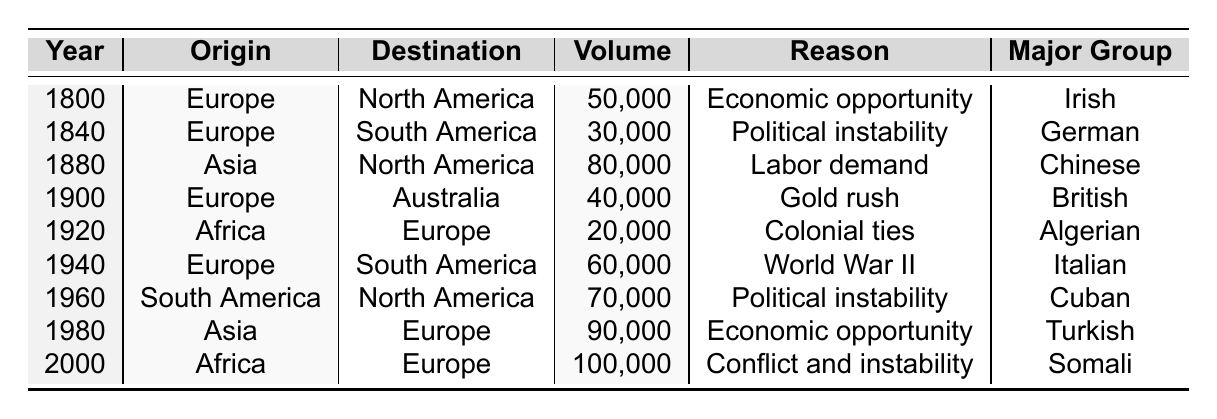What was the migration volume from Asia to North America in 1880? The table shows a migration volume of 80,000 from Asia to North America in 1880.
Answer: 80,000 Which major ethnic group migrated from South America to North America in 1960? The table indicates that the major ethnic group that migrated from South America to North America in 1960 was Cuban.
Answer: Cuban What was the primary reason for the migration from Europe to South America in 1840? According to the table, the primary reason for this migration was political instability.
Answer: Political instability Did any migration from Africa to Europe occur before 2000? The table presents data on migration from Africa to Europe in 1920, indicating that it did occur prior to 2000.
Answer: Yes What is the total migration volume from Europe to South America across all recorded years? By adding the migration volumes for Europe to South America from the years 1840 (30,000) and 1940 (60,000), we get 30,000 + 60,000 = 90,000 as the total volume.
Answer: 90,000 How many years did migration from Asia to Europe occur, according to the table? The table shows that migration from Asia to Europe occurred once in 1980, so it happened in only one year.
Answer: 1 What was the average migration volume from Africa to Europe during the years listed? The only two entries for migration from Africa to Europe are 20,000 (in 1920) and 100,000 (in 2000). The average is (20,000 + 100,000) / 2 = 60,000.
Answer: 60,000 Which year experienced the highest migration from Africa to Europe and what was the volume? The table indicates the highest migration volume from Africa to Europe occurred in 2000, with a volume of 100,000.
Answer: 2000, 100,000 What were the primary reasons for migration from Europe to South America during the years listed? The table records two reasons: in 1840, it was political instability; in 1940, it was World War II.
Answer: Political instability, World War II How does the migration volume from Asia to North America in 1880 compare to the migration from Europe to North America in 1800? The migration volume from Asia to North America in 1880 was 80,000 while from Europe in 1800 it was 50,000; hence, migration volume from Asia was higher.
Answer: Higher 